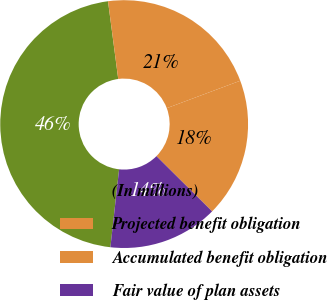Convert chart. <chart><loc_0><loc_0><loc_500><loc_500><pie_chart><fcel>(In millions)<fcel>Projected benefit obligation<fcel>Accumulated benefit obligation<fcel>Fair value of plan assets<nl><fcel>46.15%<fcel>21.39%<fcel>18.13%<fcel>14.33%<nl></chart> 